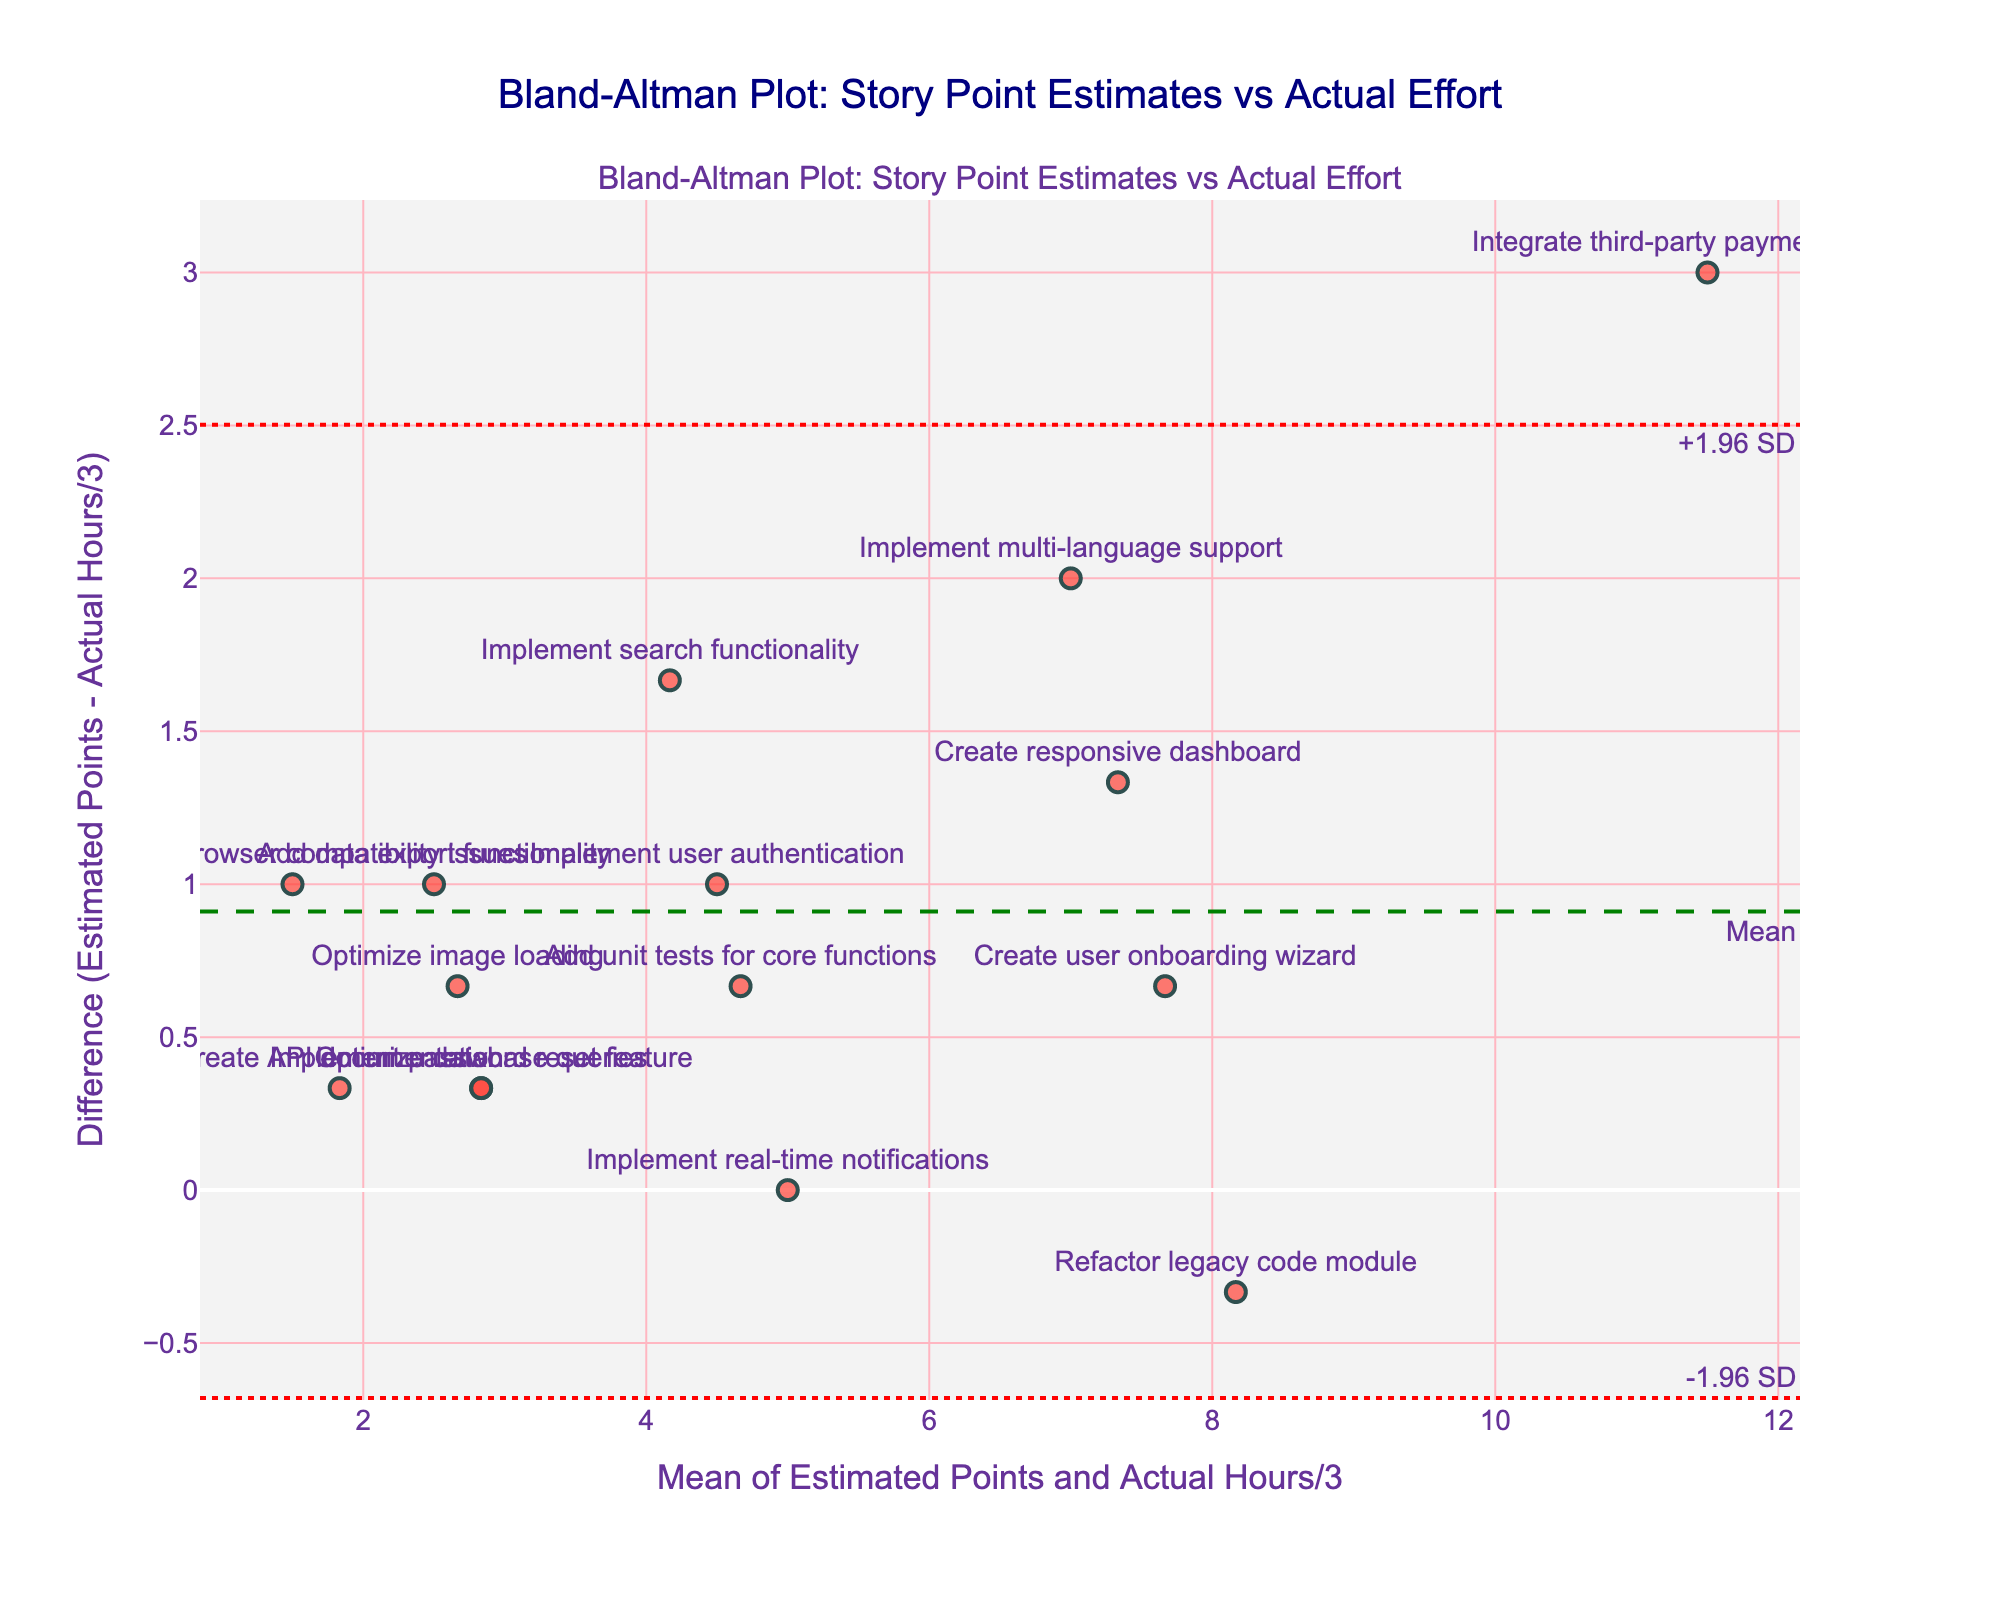What's the title of the figure? The title of the figure is displayed at the top center. It reads, "Bland-Altman Plot: Story Point Estimates vs Actual Effort".
Answer: Bland-Altman Plot: Story Point Estimates vs Actual Effort How many data points are shown in the plot? The plot contains one marker for each data point from the dataset. By counting the markers, you can determine the number of data points.
Answer: 15 What are the x-axis and y-axis labels in the plot? The x-axis label is "Mean of Estimated Points and Actual Hours/3", and the y-axis label is "Difference (Estimated Points - Actual Hours/3)". These labels are displayed at the bottom and left of the plot, respectively.
Answer: Mean of Estimated Points and Actual Hours/3, Difference (Estimated Points - Actual Hours/3) Which story has the highest positive difference between estimated points and actual hours divided by 3? To find this, look for the point with the highest y-value on the plot and check the associated story label. The "Refactor legacy code module" has the highest positive difference.
Answer: Refactor legacy code module What is the mean difference plotted on the graph? The mean difference is shown as a green dashed horizontal line marked with "Mean". This value represents the average difference between estimated points and actual hours divided by 3 for all stories.
Answer: Mean difference What are the upper and lower limits of agreement (±1.96 SD) in the plot, and why are they important? The upper and lower limits are represented by red dotted horizontal lines annotated as "+1.96 SD" and "-1.96 SD". These limits indicate the range within which most differences between estimated and actual values fall, highlighting the variability of estimation errors.
Answer: Upper and lower limits of agreement Are there any values that fall outside the limits of agreement? Examine the plot to see if any data points lie above the upper red dotted line or below the lower red dotted line. There is one data point outside the lower limit of agreement.
Answer: Yes Which story has the smallest mean of estimated points and actual hours divided by 3? To find the story with the smallest mean, look for the leftmost point on the x-axis and identify the associated story label. The "Fix cross-browser compatibility issues" has the smallest mean.
Answer: Fix cross-browser compatibility issues What can be inferred from the spread of the data points relative to the mean difference line? The spread of data points around the mean difference line indicates the consistency of estimates. A wide spread suggests high variability, while a narrow spread suggests consistent estimations. In this plot, points are widely spread, indicating varying estimation accuracy.
Answer: High variability in estimation accuracy 